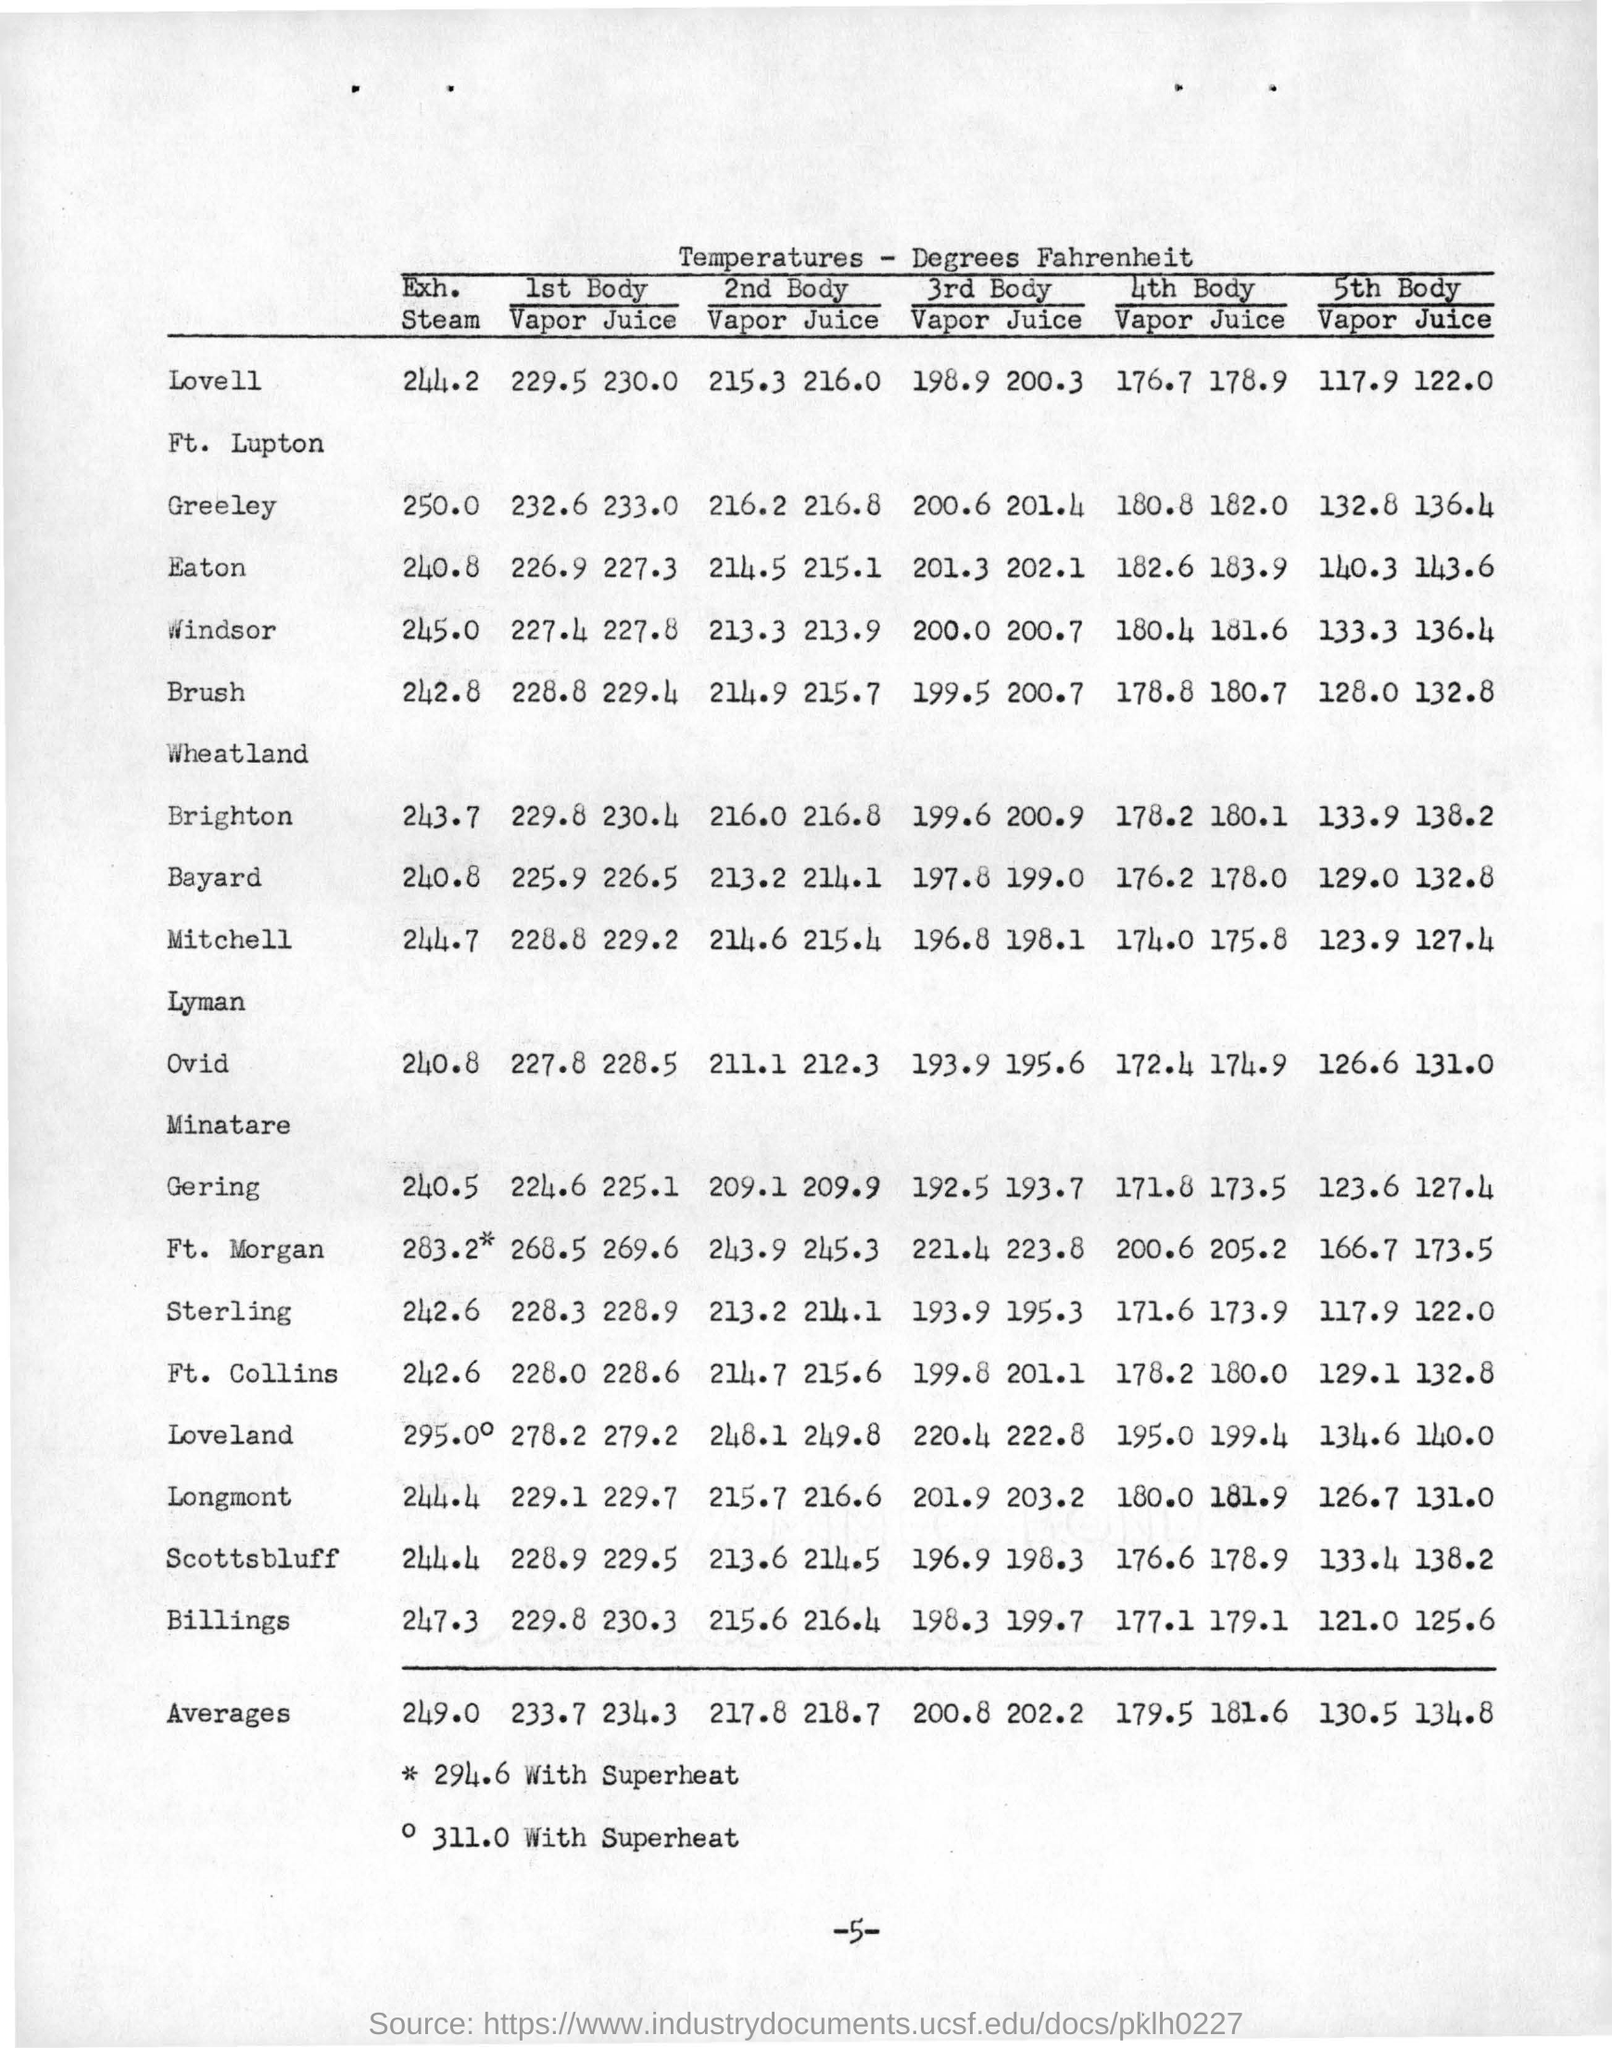Give some essential details in this illustration. The average temperature of a second body in a vapor is approximately 217.8 degrees Celsius. The temperature of the first body in vapor for Windsor is 227.4 degrees Celsius. The symbol indicates that the temperature is 294.6 degrees with superheat. The "o" symbol represents the mass flow rate in the table footnotes, and the superheat is given in the table for a mass flow rate of 311.0 grams per minute. The temperature of the fifth body in the juice for Bayard is 132.8 degrees. 